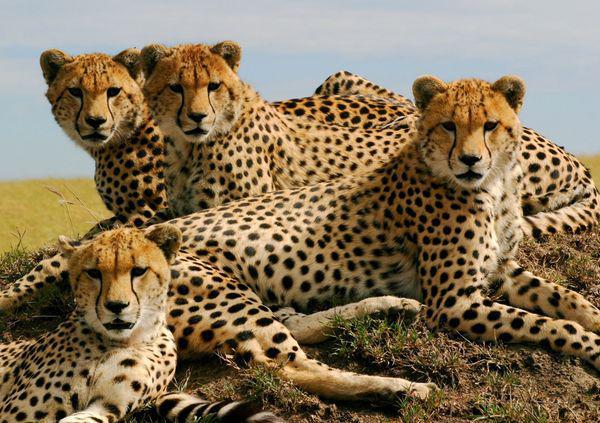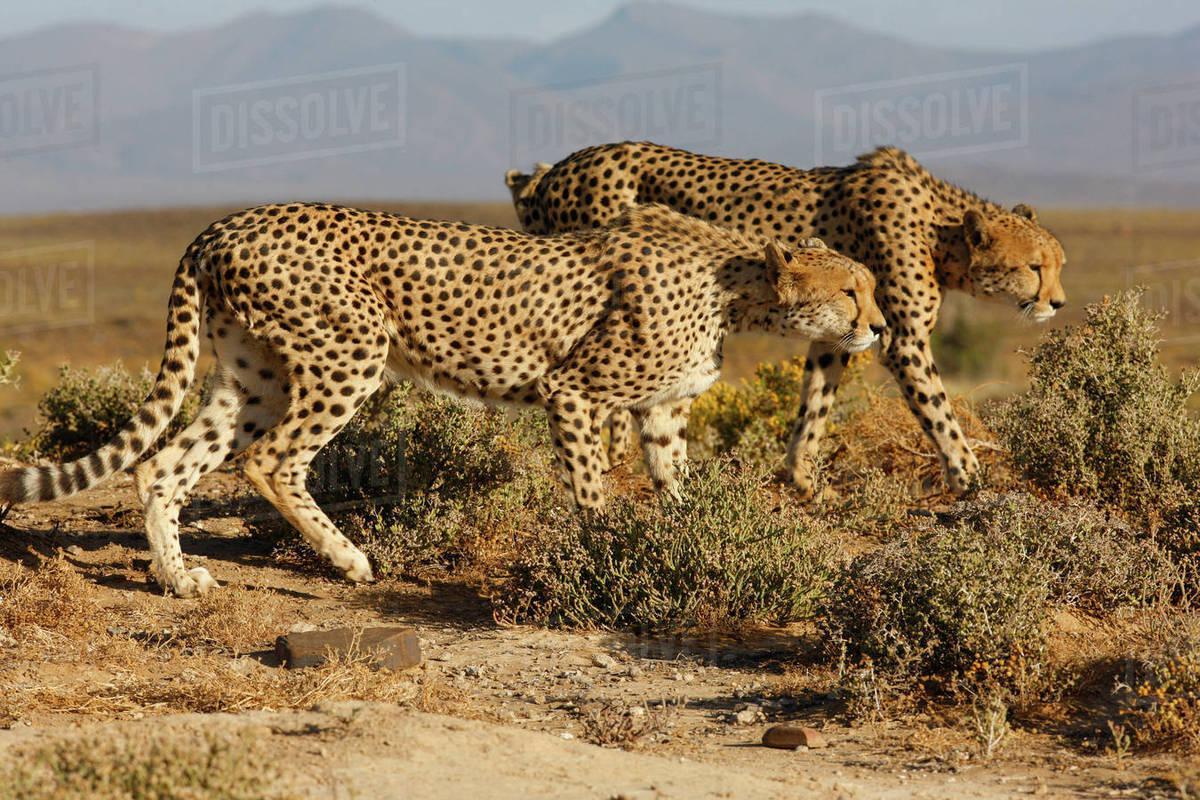The first image is the image on the left, the second image is the image on the right. Evaluate the accuracy of this statement regarding the images: "The right image contains two or less baby cheetahs.". Is it true? Answer yes or no. No. The first image is the image on the left, the second image is the image on the right. Examine the images to the left and right. Is the description "Left image shows a close group of at least four cheetahs." accurate? Answer yes or no. Yes. 